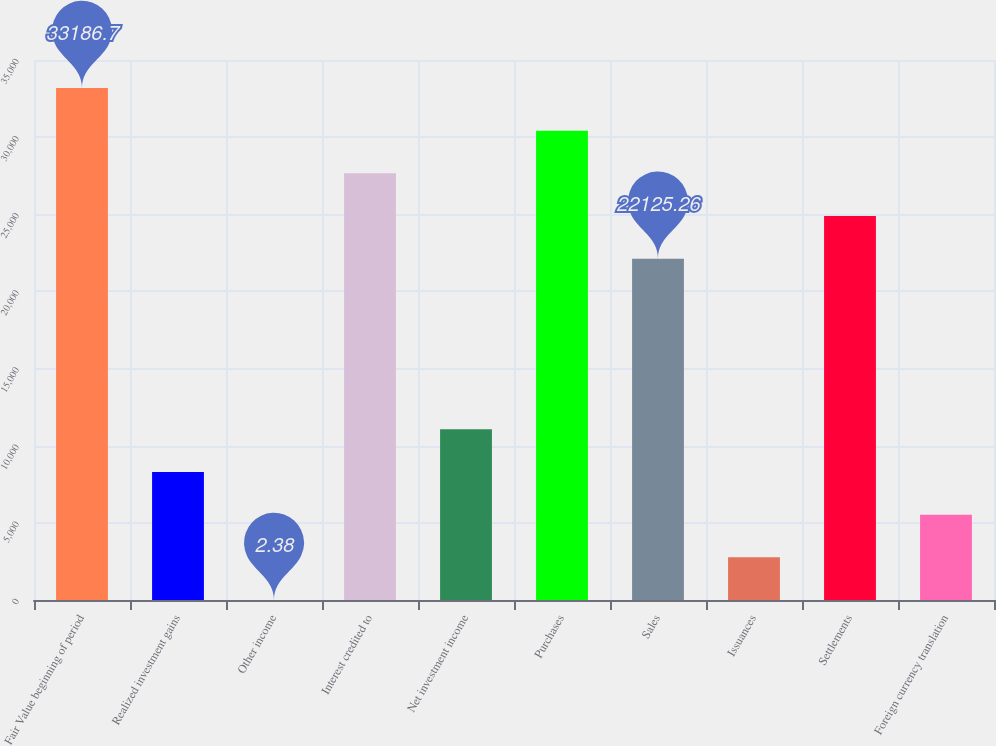Convert chart to OTSL. <chart><loc_0><loc_0><loc_500><loc_500><bar_chart><fcel>Fair Value beginning of period<fcel>Realized investment gains<fcel>Other income<fcel>Interest credited to<fcel>Net investment income<fcel>Purchases<fcel>Sales<fcel>Issuances<fcel>Settlements<fcel>Foreign currency translation<nl><fcel>33186.7<fcel>8298.46<fcel>2.38<fcel>27656<fcel>11063.8<fcel>30421.3<fcel>22125.3<fcel>2767.74<fcel>24890.6<fcel>5533.1<nl></chart> 